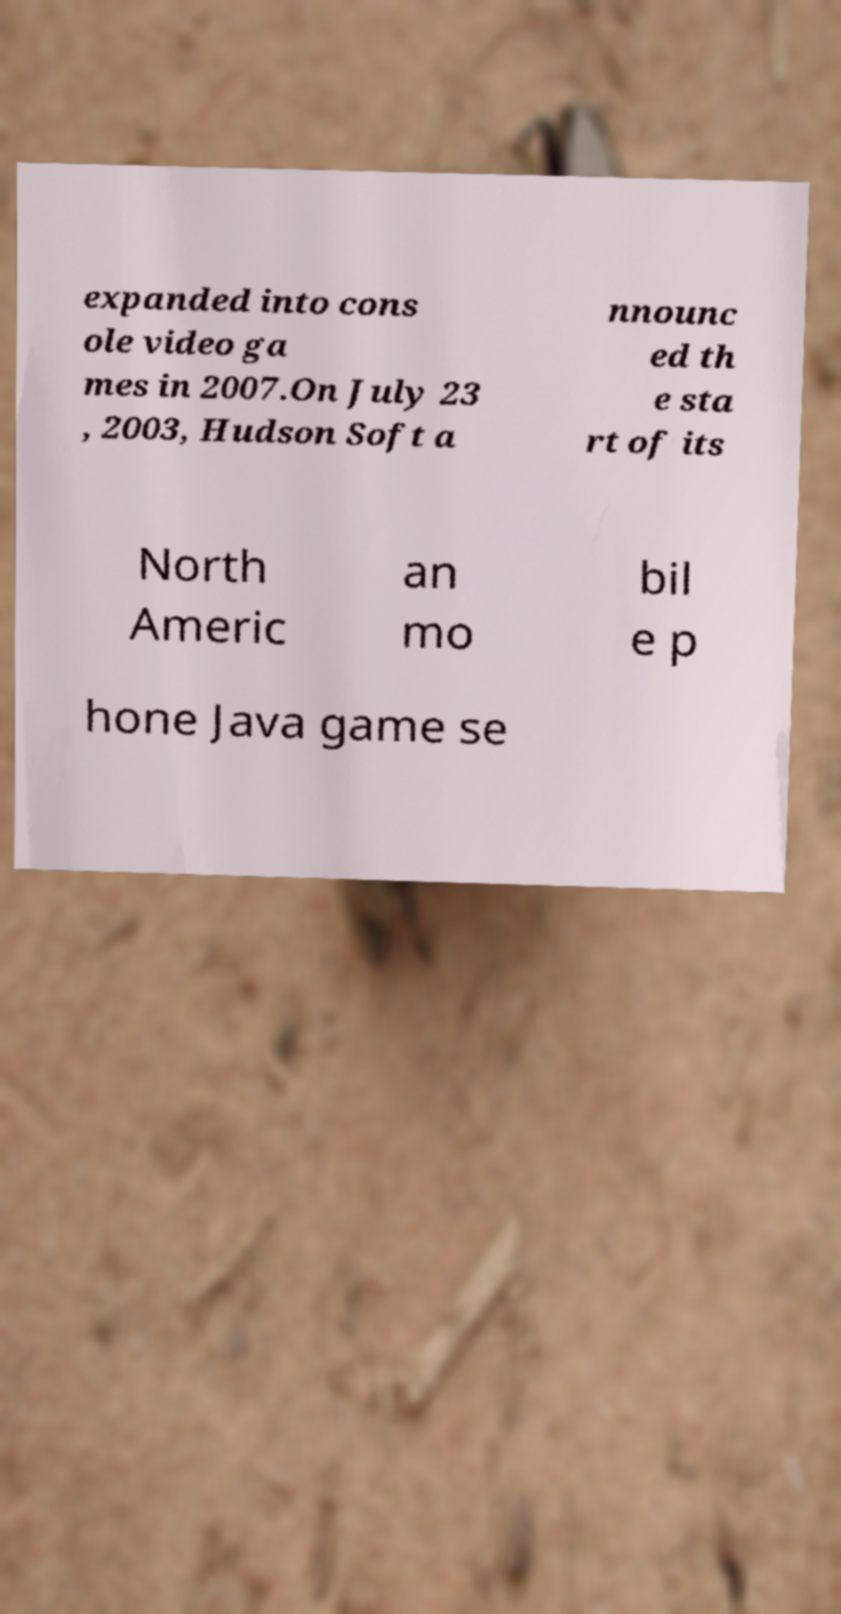For documentation purposes, I need the text within this image transcribed. Could you provide that? expanded into cons ole video ga mes in 2007.On July 23 , 2003, Hudson Soft a nnounc ed th e sta rt of its North Americ an mo bil e p hone Java game se 